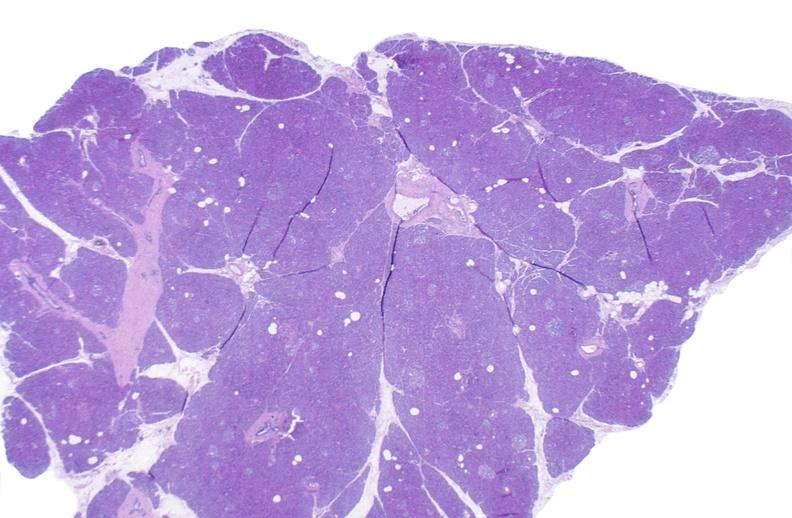where is this?
Answer the question using a single word or phrase. Pancreas 